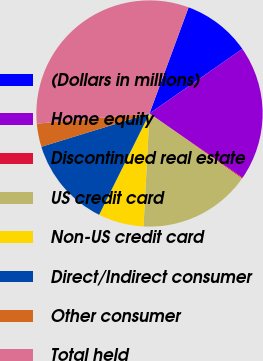Convert chart to OTSL. <chart><loc_0><loc_0><loc_500><loc_500><pie_chart><fcel>(Dollars in millions)<fcel>Home equity<fcel>Discontinued real estate<fcel>US credit card<fcel>Non-US credit card<fcel>Direct/Indirect consumer<fcel>Other consumer<fcel>Total held<nl><fcel>9.71%<fcel>19.28%<fcel>0.13%<fcel>16.09%<fcel>6.51%<fcel>12.9%<fcel>3.32%<fcel>32.05%<nl></chart> 